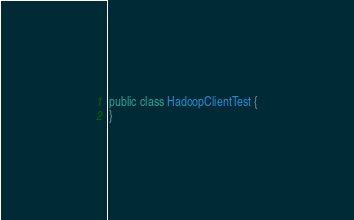<code> <loc_0><loc_0><loc_500><loc_500><_Java_>public class HadoopClientTest {
}


</code> 